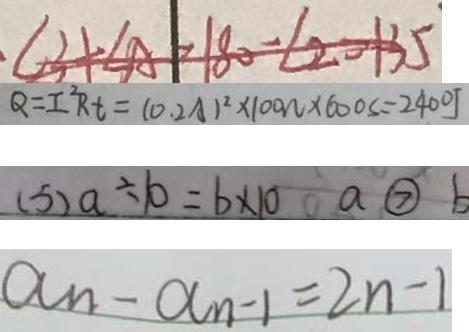<formula> <loc_0><loc_0><loc_500><loc_500>\angle 3 + \angle A = 1 8 0 - \angle 2 = 1 3 5 
 Q = I ^ { 2 } R t = ( 0 . 2 A ) ^ { 2 } \times 1 0 0 w \times 6 0 0 s = 2 4 0 0 J 
 ( 5 ) a \div 1 0 = b \times 1 0 a \textcircled { > } b 
 a _ { n } - a _ { n - 1 } = 2 n - 1</formula> 